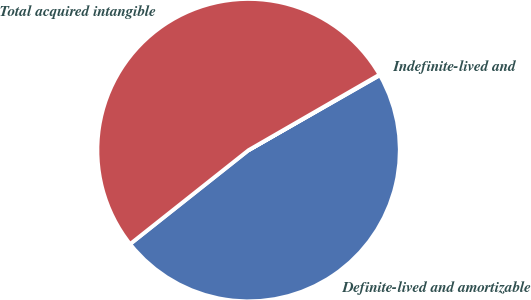Convert chart. <chart><loc_0><loc_0><loc_500><loc_500><pie_chart><fcel>Definite-lived and amortizable<fcel>Indefinite-lived and<fcel>Total acquired intangible<nl><fcel>47.59%<fcel>0.07%<fcel>52.34%<nl></chart> 